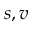<formula> <loc_0><loc_0><loc_500><loc_500>s , v</formula> 